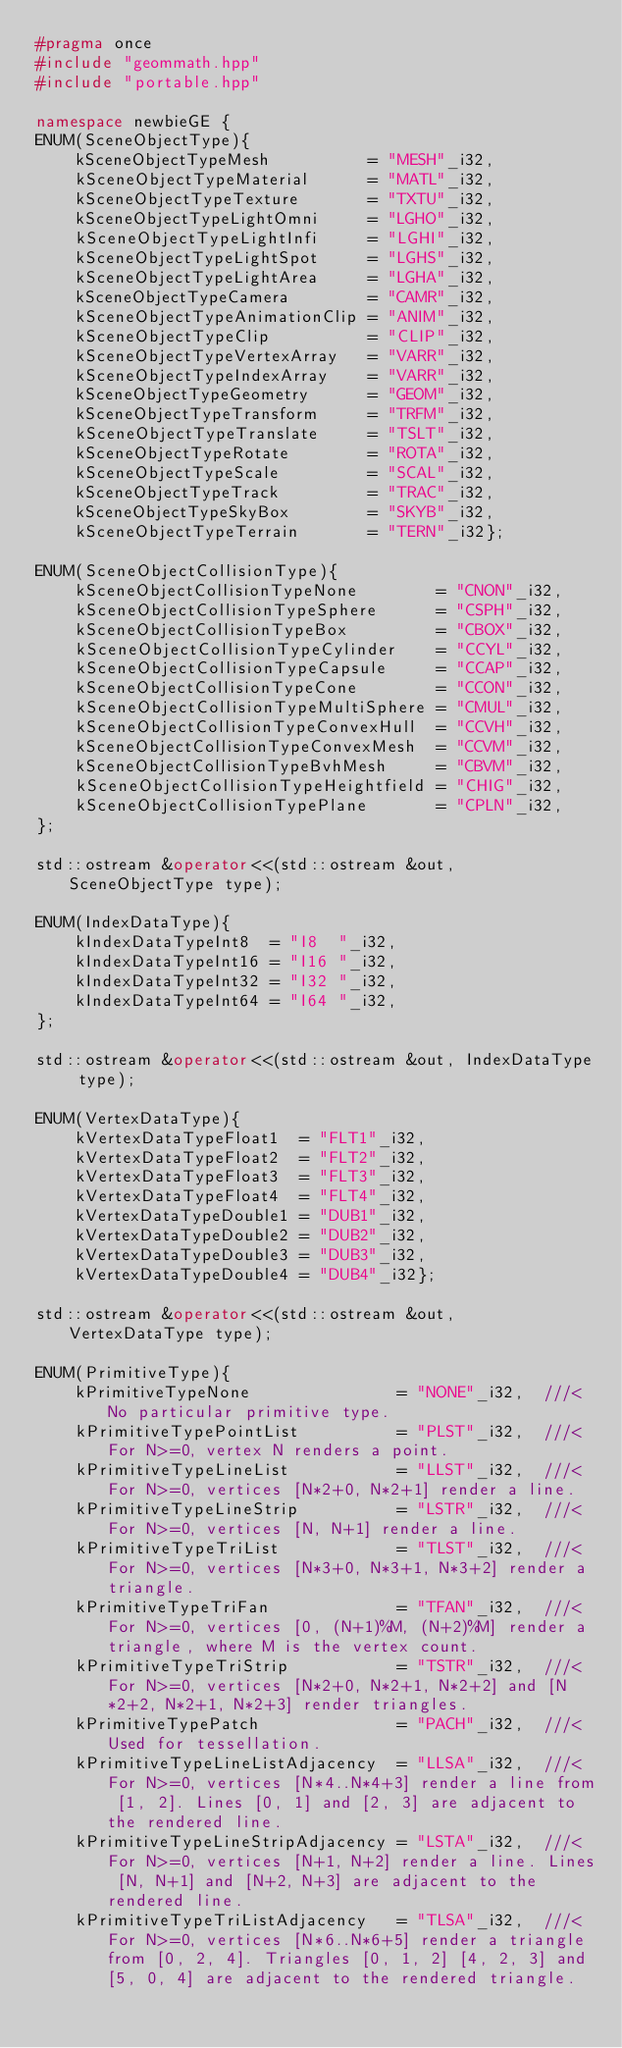Convert code to text. <code><loc_0><loc_0><loc_500><loc_500><_C++_>#pragma once
#include "geommath.hpp"
#include "portable.hpp"

namespace newbieGE {
ENUM(SceneObjectType){
    kSceneObjectTypeMesh          = "MESH"_i32,
    kSceneObjectTypeMaterial      = "MATL"_i32,
    kSceneObjectTypeTexture       = "TXTU"_i32,
    kSceneObjectTypeLightOmni     = "LGHO"_i32,
    kSceneObjectTypeLightInfi     = "LGHI"_i32,
    kSceneObjectTypeLightSpot     = "LGHS"_i32,
    kSceneObjectTypeLightArea     = "LGHA"_i32,
    kSceneObjectTypeCamera        = "CAMR"_i32,
    kSceneObjectTypeAnimationClip = "ANIM"_i32,
    kSceneObjectTypeClip          = "CLIP"_i32,
    kSceneObjectTypeVertexArray   = "VARR"_i32,
    kSceneObjectTypeIndexArray    = "VARR"_i32,
    kSceneObjectTypeGeometry      = "GEOM"_i32,
    kSceneObjectTypeTransform     = "TRFM"_i32,
    kSceneObjectTypeTranslate     = "TSLT"_i32,
    kSceneObjectTypeRotate        = "ROTA"_i32,
    kSceneObjectTypeScale         = "SCAL"_i32,
    kSceneObjectTypeTrack         = "TRAC"_i32,
    kSceneObjectTypeSkyBox        = "SKYB"_i32,
    kSceneObjectTypeTerrain       = "TERN"_i32};

ENUM(SceneObjectCollisionType){
    kSceneObjectCollisionTypeNone        = "CNON"_i32,
    kSceneObjectCollisionTypeSphere      = "CSPH"_i32,
    kSceneObjectCollisionTypeBox         = "CBOX"_i32,
    kSceneObjectCollisionTypeCylinder    = "CCYL"_i32,
    kSceneObjectCollisionTypeCapsule     = "CCAP"_i32,
    kSceneObjectCollisionTypeCone        = "CCON"_i32,
    kSceneObjectCollisionTypeMultiSphere = "CMUL"_i32,
    kSceneObjectCollisionTypeConvexHull  = "CCVH"_i32,
    kSceneObjectCollisionTypeConvexMesh  = "CCVM"_i32,
    kSceneObjectCollisionTypeBvhMesh     = "CBVM"_i32,
    kSceneObjectCollisionTypeHeightfield = "CHIG"_i32,
    kSceneObjectCollisionTypePlane       = "CPLN"_i32,
};

std::ostream &operator<<(std::ostream &out, SceneObjectType type);

ENUM(IndexDataType){
    kIndexDataTypeInt8  = "I8  "_i32,
    kIndexDataTypeInt16 = "I16 "_i32,
    kIndexDataTypeInt32 = "I32 "_i32,
    kIndexDataTypeInt64 = "I64 "_i32,
};

std::ostream &operator<<(std::ostream &out, IndexDataType type);

ENUM(VertexDataType){
    kVertexDataTypeFloat1  = "FLT1"_i32,
    kVertexDataTypeFloat2  = "FLT2"_i32,
    kVertexDataTypeFloat3  = "FLT3"_i32,
    kVertexDataTypeFloat4  = "FLT4"_i32,
    kVertexDataTypeDouble1 = "DUB1"_i32,
    kVertexDataTypeDouble2 = "DUB2"_i32,
    kVertexDataTypeDouble3 = "DUB3"_i32,
    kVertexDataTypeDouble4 = "DUB4"_i32};

std::ostream &operator<<(std::ostream &out, VertexDataType type);

ENUM(PrimitiveType){
    kPrimitiveTypeNone               = "NONE"_i32,  ///< No particular primitive type.
    kPrimitiveTypePointList          = "PLST"_i32,  ///< For N>=0, vertex N renders a point.
    kPrimitiveTypeLineList           = "LLST"_i32,  ///< For N>=0, vertices [N*2+0, N*2+1] render a line.
    kPrimitiveTypeLineStrip          = "LSTR"_i32,  ///< For N>=0, vertices [N, N+1] render a line.
    kPrimitiveTypeTriList            = "TLST"_i32,  ///< For N>=0, vertices [N*3+0, N*3+1, N*3+2] render a triangle.
    kPrimitiveTypeTriFan             = "TFAN"_i32,  ///< For N>=0, vertices [0, (N+1)%M, (N+2)%M] render a triangle, where M is the vertex count.
    kPrimitiveTypeTriStrip           = "TSTR"_i32,  ///< For N>=0, vertices [N*2+0, N*2+1, N*2+2] and [N*2+2, N*2+1, N*2+3] render triangles.
    kPrimitiveTypePatch              = "PACH"_i32,  ///< Used for tessellation.
    kPrimitiveTypeLineListAdjacency  = "LLSA"_i32,  ///< For N>=0, vertices [N*4..N*4+3] render a line from [1, 2]. Lines [0, 1] and [2, 3] are adjacent to the rendered line.
    kPrimitiveTypeLineStripAdjacency = "LSTA"_i32,  ///< For N>=0, vertices [N+1, N+2] render a line. Lines [N, N+1] and [N+2, N+3] are adjacent to the rendered line.
    kPrimitiveTypeTriListAdjacency   = "TLSA"_i32,  ///< For N>=0, vertices [N*6..N*6+5] render a triangle from [0, 2, 4]. Triangles [0, 1, 2] [4, 2, 3] and [5, 0, 4] are adjacent to the rendered triangle.</code> 